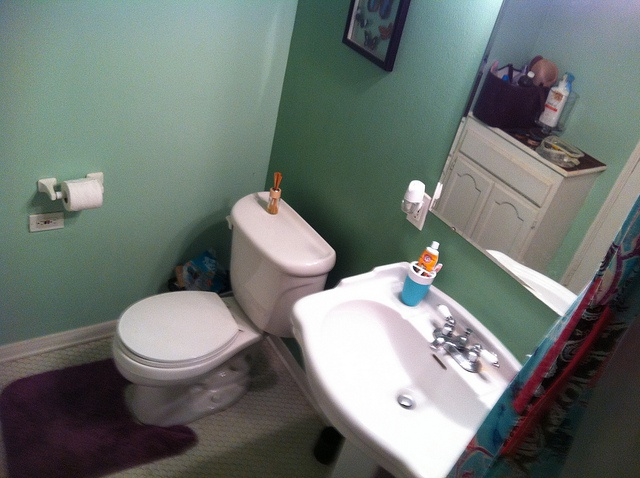Describe the objects in this image and their specific colors. I can see sink in gray, white, darkgray, and lightgray tones, toilet in gray, lightgray, and darkgray tones, bottle in gray, darkgray, and brown tones, vase in gray, salmon, darkgray, and brown tones, and toothbrush in gray, lavender, lightpink, pink, and salmon tones in this image. 